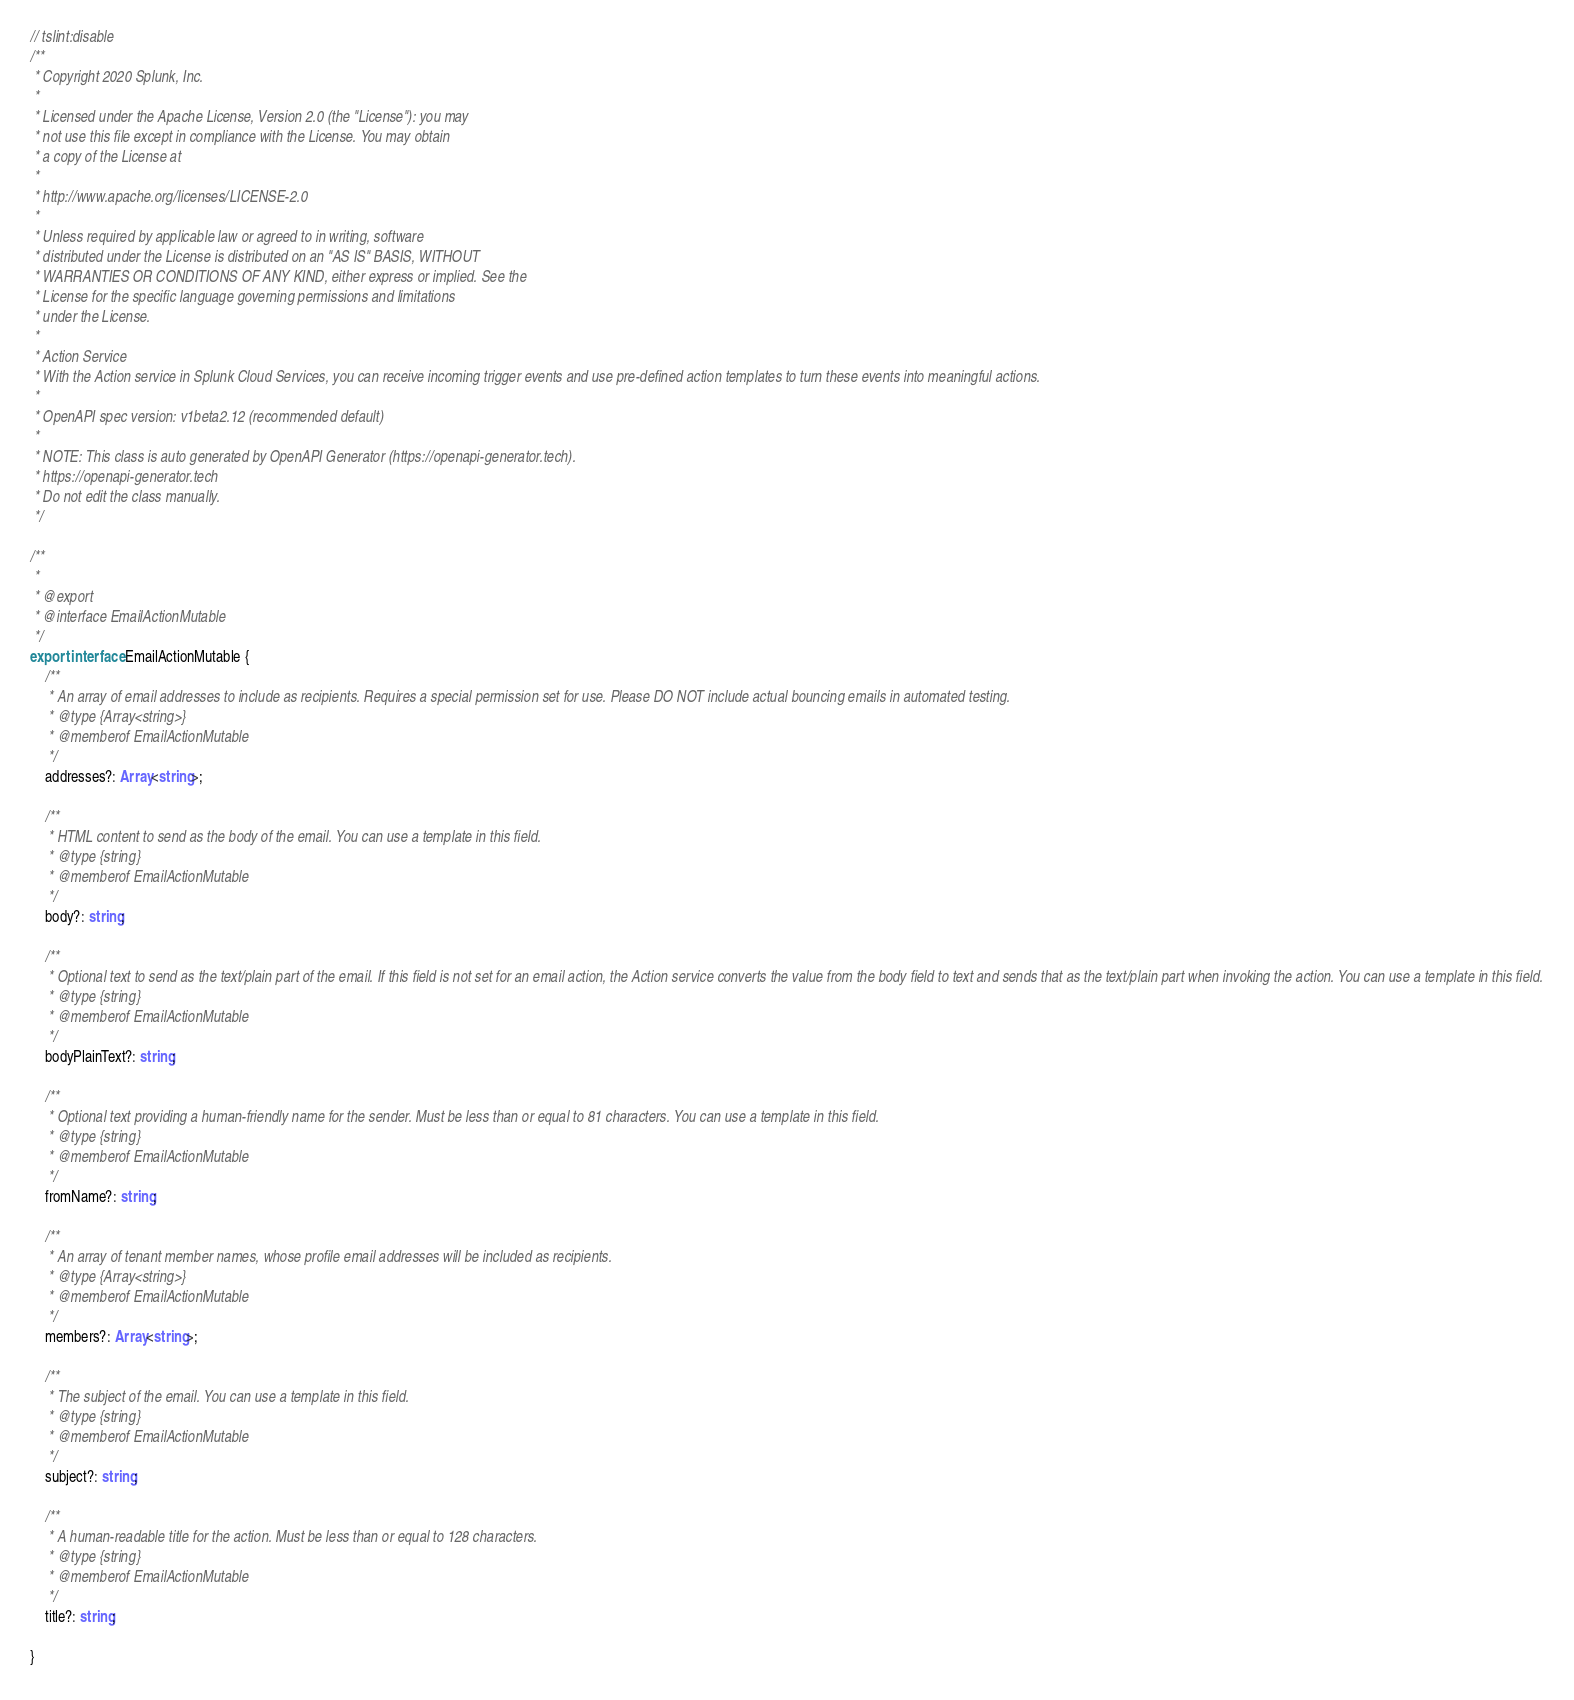Convert code to text. <code><loc_0><loc_0><loc_500><loc_500><_TypeScript_>// tslint:disable
/**
 * Copyright 2020 Splunk, Inc.
 *
 * Licensed under the Apache License, Version 2.0 (the "License"): you may
 * not use this file except in compliance with the License. You may obtain
 * a copy of the License at
 *
 * http://www.apache.org/licenses/LICENSE-2.0
 *
 * Unless required by applicable law or agreed to in writing, software
 * distributed under the License is distributed on an "AS IS" BASIS, WITHOUT
 * WARRANTIES OR CONDITIONS OF ANY KIND, either express or implied. See the
 * License for the specific language governing permissions and limitations
 * under the License.
 *
 * Action Service
 * With the Action service in Splunk Cloud Services, you can receive incoming trigger events and use pre-defined action templates to turn these events into meaningful actions. 
 *
 * OpenAPI spec version: v1beta2.12 (recommended default)
 *
 * NOTE: This class is auto generated by OpenAPI Generator (https://openapi-generator.tech).
 * https://openapi-generator.tech
 * Do not edit the class manually.
 */

/**
 *
 * @export
 * @interface EmailActionMutable
 */
export interface EmailActionMutable {
    /**
     * An array of email addresses to include as recipients. Requires a special permission set for use. Please DO NOT include actual bouncing emails in automated testing. 
     * @type {Array<string>}
     * @memberof EmailActionMutable
     */
    addresses?: Array<string>;

    /**
     * HTML content to send as the body of the email. You can use a template in this field.
     * @type {string}
     * @memberof EmailActionMutable
     */
    body?: string;

    /**
     * Optional text to send as the text/plain part of the email. If this field is not set for an email action, the Action service converts the value from the body field to text and sends that as the text/plain part when invoking the action. You can use a template in this field.
     * @type {string}
     * @memberof EmailActionMutable
     */
    bodyPlainText?: string;

    /**
     * Optional text providing a human-friendly name for the sender. Must be less than or equal to 81 characters. You can use a template in this field.
     * @type {string}
     * @memberof EmailActionMutable
     */
    fromName?: string;

    /**
     * An array of tenant member names, whose profile email addresses will be included as recipients.
     * @type {Array<string>}
     * @memberof EmailActionMutable
     */
    members?: Array<string>;

    /**
     * The subject of the email. You can use a template in this field.
     * @type {string}
     * @memberof EmailActionMutable
     */
    subject?: string;

    /**
     * A human-readable title for the action. Must be less than or equal to 128 characters.
     * @type {string}
     * @memberof EmailActionMutable
     */
    title?: string;

}

</code> 